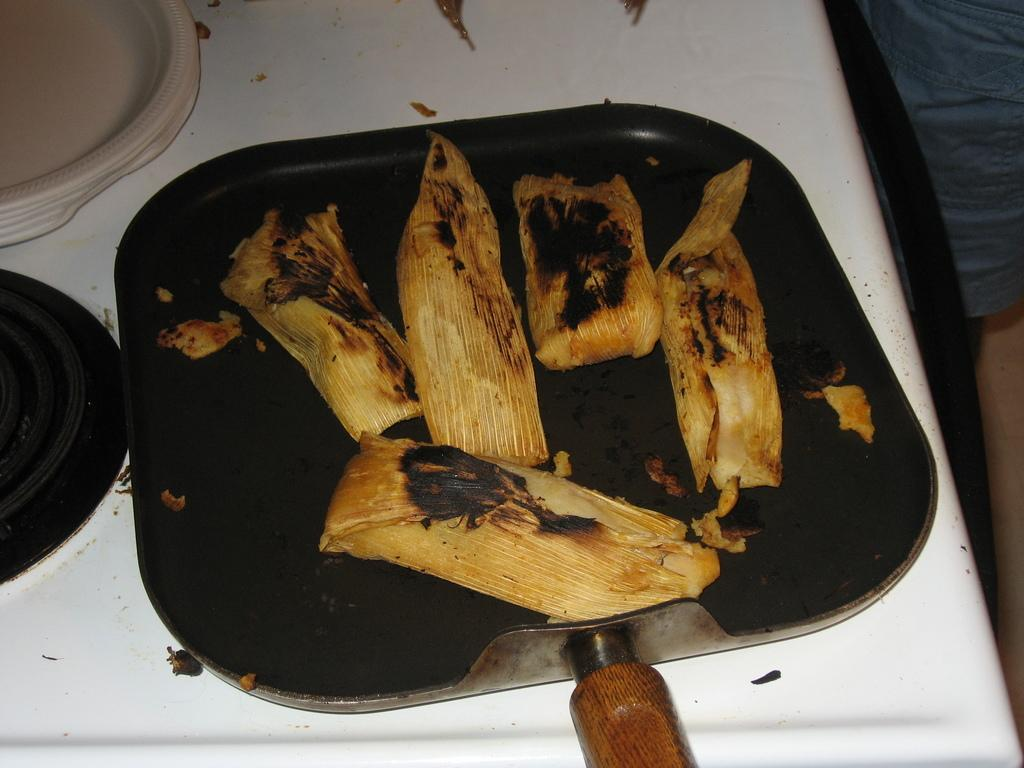What is the main subject in the foreground of the image? There is a tamale on a pan in the foreground of the image. What else can be seen on the white surface in the foreground? There are platters on the white surface in the foreground of the image. What type of badge is the monkey wearing while transporting the tamale in the image? There is no monkey or badge present in the image; it features a tamale on a pan and platters on a white surface. 